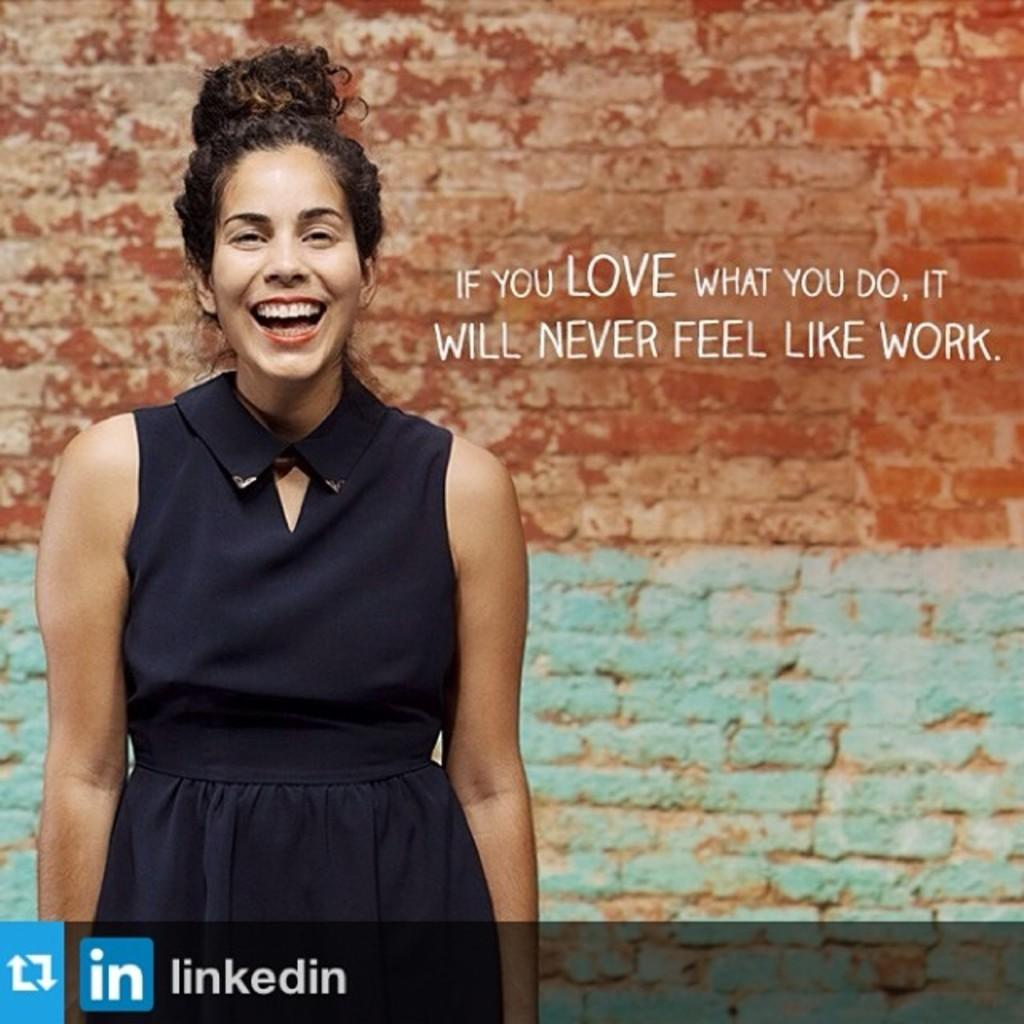What can be found in the right corner of the image? There is text in the right corner of the image. What is located at the bottom of the image? There is text and a logo at the bottom of the image. Who or what is in the foreground of the image? There is a person in the foreground of the image. What is visible in the background of the image? There is a wall in the background of the image. How does the person in the image increase the size of the sack? There is no sack present in the image, and therefore no such action can be observed. 